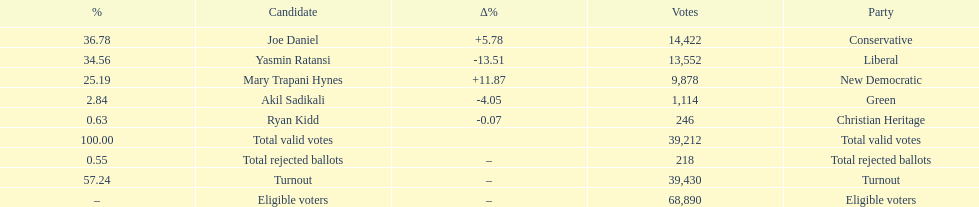Which candidate had the most votes? Joe Daniel. 